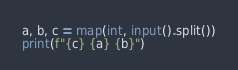Convert code to text. <code><loc_0><loc_0><loc_500><loc_500><_Python_>a, b, c = map(int, input().split())
print(f"{c} {a} {b}")</code> 